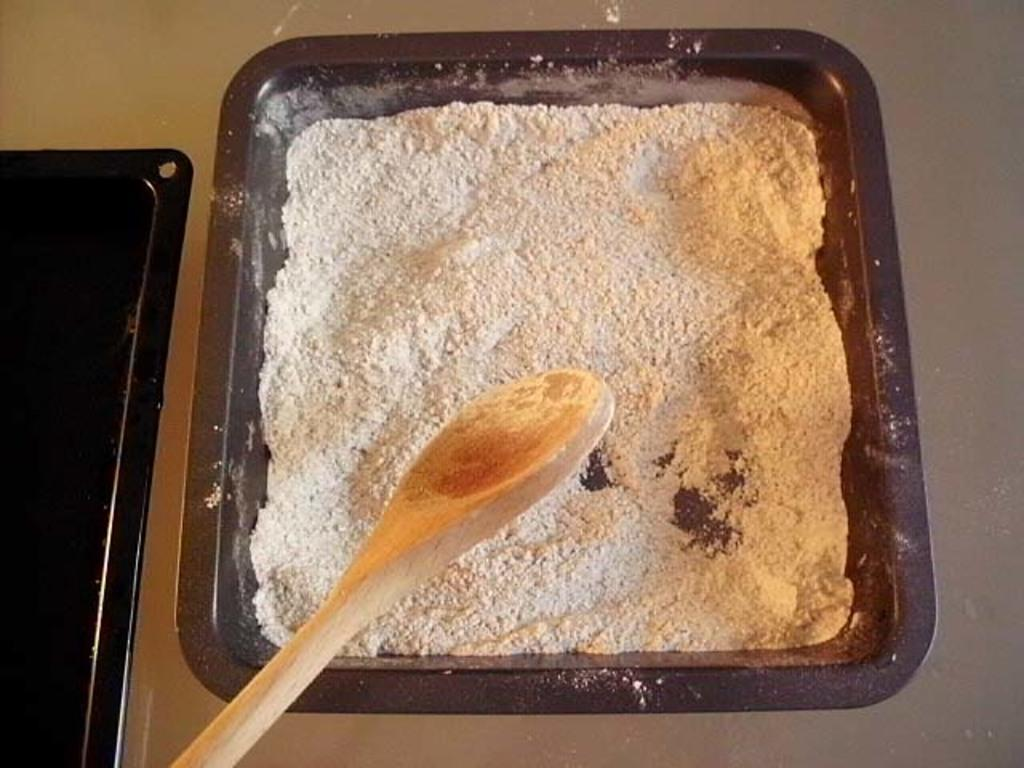What is in the bowl that is visible in the image? There is a bowl with powder in the image. Where is the bowl located in the image? The bowl is on a surface in the image. What utensil is present on the surface in the image? There is a wooden spoon on the surface in the image. What type of grain is being harvested in the image? There is no indication of any grain or harvesting activity in the image; it only shows a bowl with powder and a wooden spoon on a surface. 